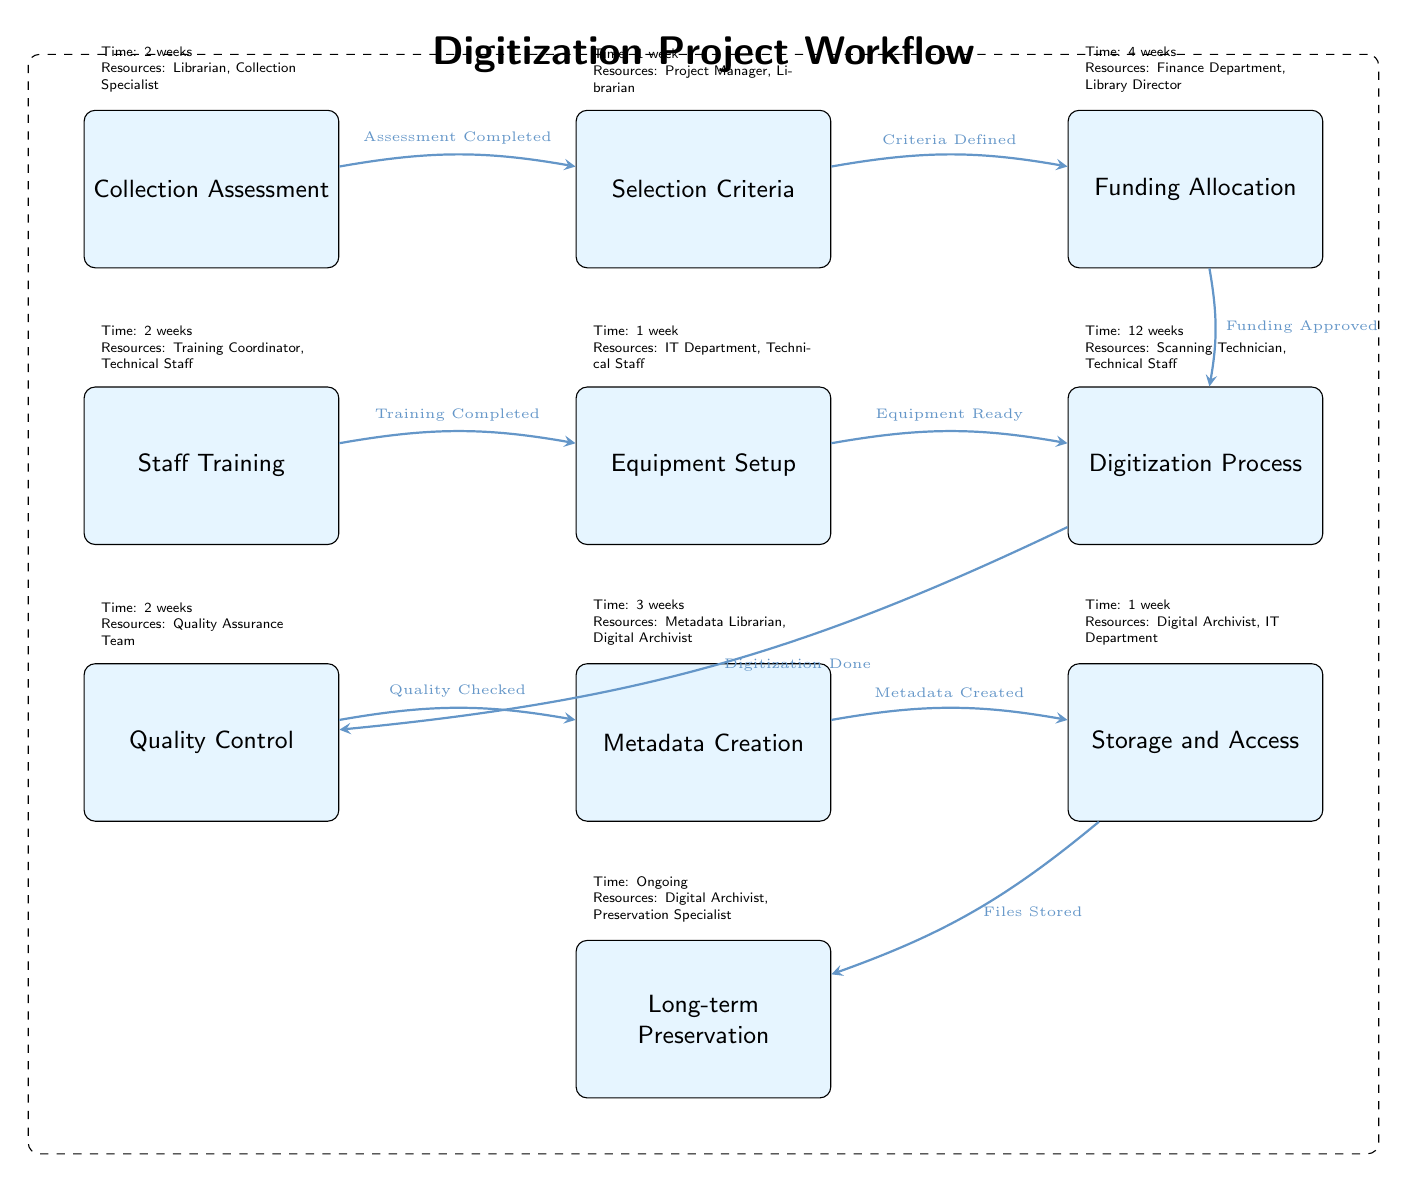What is the first step in the digitization process? The first step in the diagram is "Collection Assessment," indicated as the leftmost node.
Answer: Collection Assessment How many weeks are allocated for the "Digitization Process"? The node "Digitization Process" specifies a time allocation of 12 weeks for this step.
Answer: 12 weeks Which team is responsible for "Quality Control"? The "Quality Control" node highlights that the "Quality Assurance Team" is responsible for this step, as indicated next to the node.
Answer: Quality Assurance Team What resource is needed for "Funding Allocation"? The "Funding Allocation" node lists "Finance Department, Library Director" as required resources for this step.
Answer: Finance Department, Library Director After "Equipment Setup," what is the next step? The diagram shows that after "Equipment Setup," the next step is "Digitization Process," indicated by the arrow pointing to this node.
Answer: Digitization Process What is the total amount of time needed for steps from "Selection Criteria" to "Storage and Access"? The steps from "Selection Criteria" (1 week) to "Storage and Access" (1 week) consist of the following total time: 1 week (selection) + 4 weeks (funding) + 12 weeks (digitization) + 2 weeks (quality) + 3 weeks (metadata) + 1 week (storage) = 23 weeks.
Answer: 23 weeks Which node directly follows "Staff Training"? The flow of the diagram indicates that "Equipment Setup" directly follows the "Staff Training" step with an arrow connecting both nodes.
Answer: Equipment Setup What is the ongoing time requirement for "Long-term Preservation"? The diagram shows the "Long-term Preservation" step as having an ongoing time requirement, with no specific end indicated, denoted by the term "Ongoing."
Answer: Ongoing 